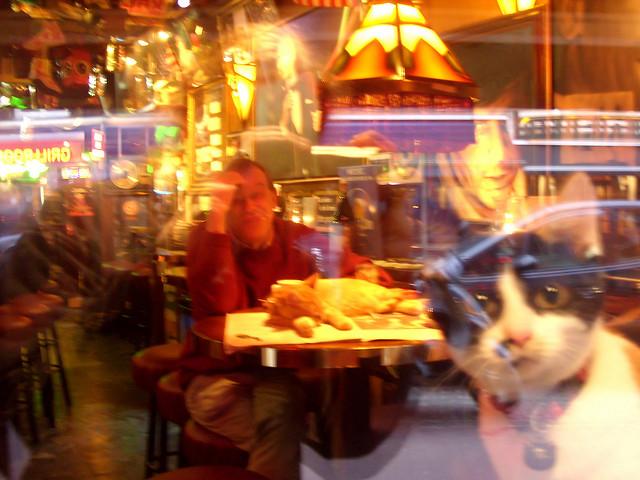Is the cat asleep?
Short answer required. No. What is on the table?
Concise answer only. Cat. Is this a restaurant?
Be succinct. Yes. 